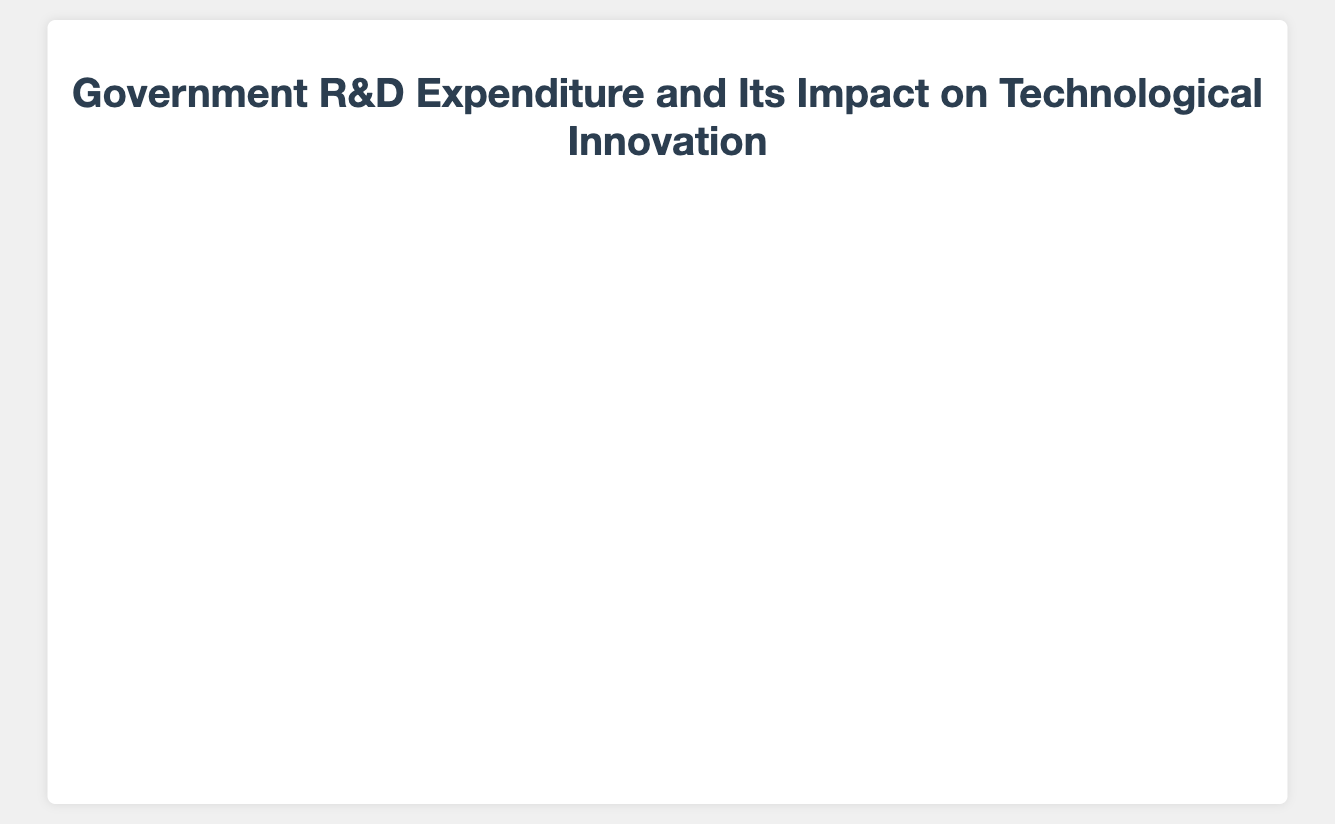What is the title of the figure? The title is mentioned at the top of the figure, inside the layout element.
Answer: Government R&D Impact on Innovation by Industry What industry has the highest technological innovation index? On the y-axis, the highest point represents the highest technological innovation index. Cross-referencing that point, the text labels indicate the industry.
Answer: Information Technology What's the range of government R&D expenditure represented in the figure? The government R&D expenditure is displayed on the x-axis. By looking at the axis range, it starts from 0.5 and goes up to 1.6 billion dollars.
Answer: $0.5B to $1.6B How does the Innovative Index of Pharmaceuticals compare to that of Biotechnology? By locating the positions on the y-axis and cross-referencing the text labels for Pharmaceuticals and Biotechnology, we see that Pharmaceuticals has an innovation index of 8.2 and Biotechnology has 8.3.
Answer: Biotechnology has a slightly higher innovation index Which industry received approximately $0.9 billion in government R&D expenditure and what was its Technological Innovation Index? Locating the point at $0.9 billion on the x-axis and cross-referencing the text labels, we see that Electronics and Biotechnology received that expenditure. Their innovation indexes are 7.9 and 8.3, respectively.
Answer: Electronics (Innovation Index: 7.9) and Biotechnology (Innovation Index: 8.3) Which industries have a number of patents above 160? The size of the bubble represents the number of patents. Finding the largest bubbles and checking the hover text reveals that Pharmaceuticals and Renewable Energy have more than 160 patents.
Answer: Pharmaceuticals and Renewable Energy What is the total number of patents for Aerospace and Automotive combined? From the hover text, Aerospace has 120 patents and Automotive has 90. Summing them up gives 120 + 90 = 210.
Answer: 210 Compare the government R&D expenditure of Agriculture and Telecommunications. Which industry received more funding? On the x-axis, locating both points for Agriculture and Telecommunications reveals that Telecommunications received $0.7 billion and Agriculture received $0.6 billion.
Answer: Telecommunications received more funding What is the average Technological Innovation Index of the Industries over $1 Billion in R&D Expenditure? The industries are Aerospace (7.8), Pharmaceuticals (8.2), Information Technology (8.5), and Renewable Energy (8.0). Summing these and dividing by 4 gives (7.8 + 8.2 + 8.5 + 8.0) / 4 = 8.125.
Answer: 8.125 Which two industries have the closest average Technological Innovation Index? By comparing the innovation indexes of all industries, Agriculture (6.8) and Manufacturing (7.0) are the closest, with a difference of only 0.2.
Answer: Agriculture and Manufacturing 